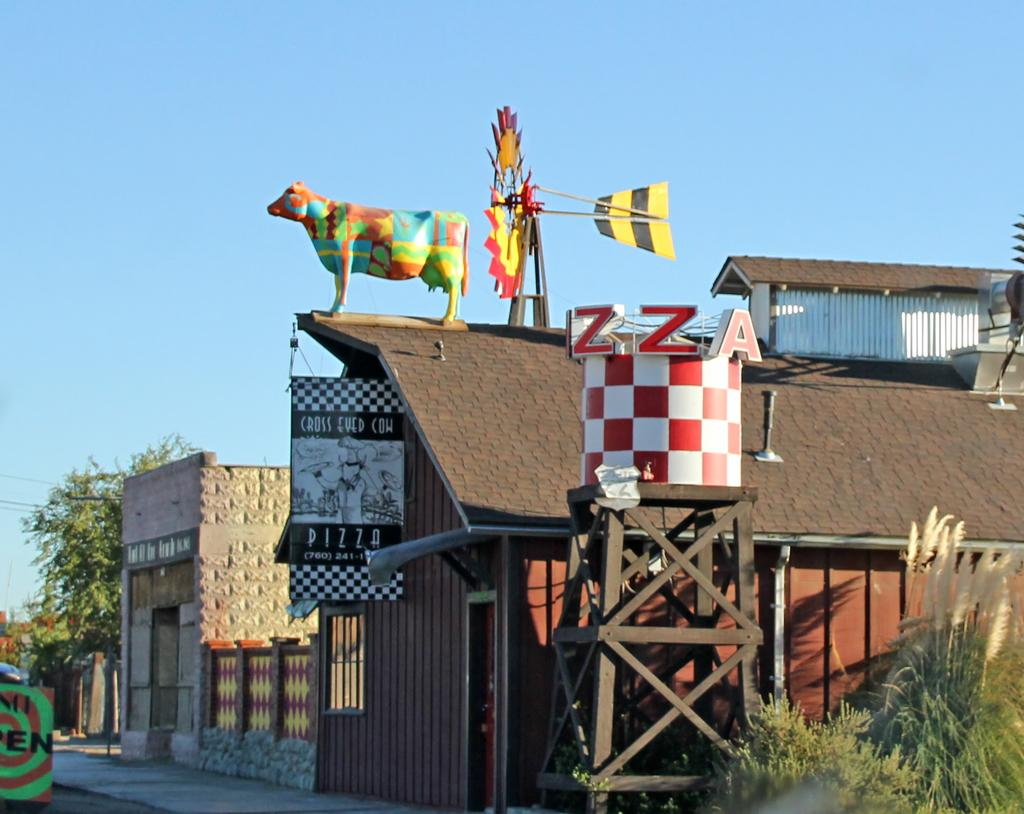What is the main object on the wooden stand in the image? There is a tank on a wooden stand in the image. What type of living organisms can be seen in the image? Plants and a cow statue are visible in the image. What type of structure is present in the image? There is a wooden house in the image. What is attached to the wall in the image? There is a banner in the image. What type of structure is present near the wooden house? There is a board in the image. What type of natural environment is visible in the image? Trees are visible in the image. What else can be seen in the image? There are wires in the image. What is the color of the sky in the background of the image? The sky in the background is pale blue. How many days does the week last in the image? The concept of a week is not present in the image, as it is a visual representation of objects and structures. 